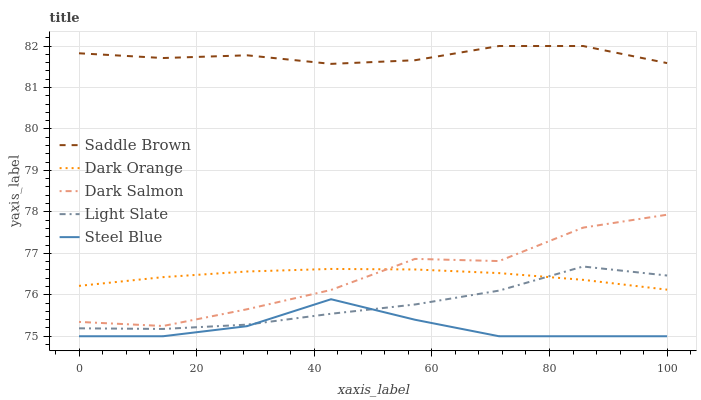Does Steel Blue have the minimum area under the curve?
Answer yes or no. Yes. Does Saddle Brown have the maximum area under the curve?
Answer yes or no. Yes. Does Dark Orange have the minimum area under the curve?
Answer yes or no. No. Does Dark Orange have the maximum area under the curve?
Answer yes or no. No. Is Dark Orange the smoothest?
Answer yes or no. Yes. Is Dark Salmon the roughest?
Answer yes or no. Yes. Is Steel Blue the smoothest?
Answer yes or no. No. Is Steel Blue the roughest?
Answer yes or no. No. Does Steel Blue have the lowest value?
Answer yes or no. Yes. Does Dark Orange have the lowest value?
Answer yes or no. No. Does Saddle Brown have the highest value?
Answer yes or no. Yes. Does Dark Orange have the highest value?
Answer yes or no. No. Is Light Slate less than Saddle Brown?
Answer yes or no. Yes. Is Dark Orange greater than Steel Blue?
Answer yes or no. Yes. Does Dark Salmon intersect Dark Orange?
Answer yes or no. Yes. Is Dark Salmon less than Dark Orange?
Answer yes or no. No. Is Dark Salmon greater than Dark Orange?
Answer yes or no. No. Does Light Slate intersect Saddle Brown?
Answer yes or no. No. 